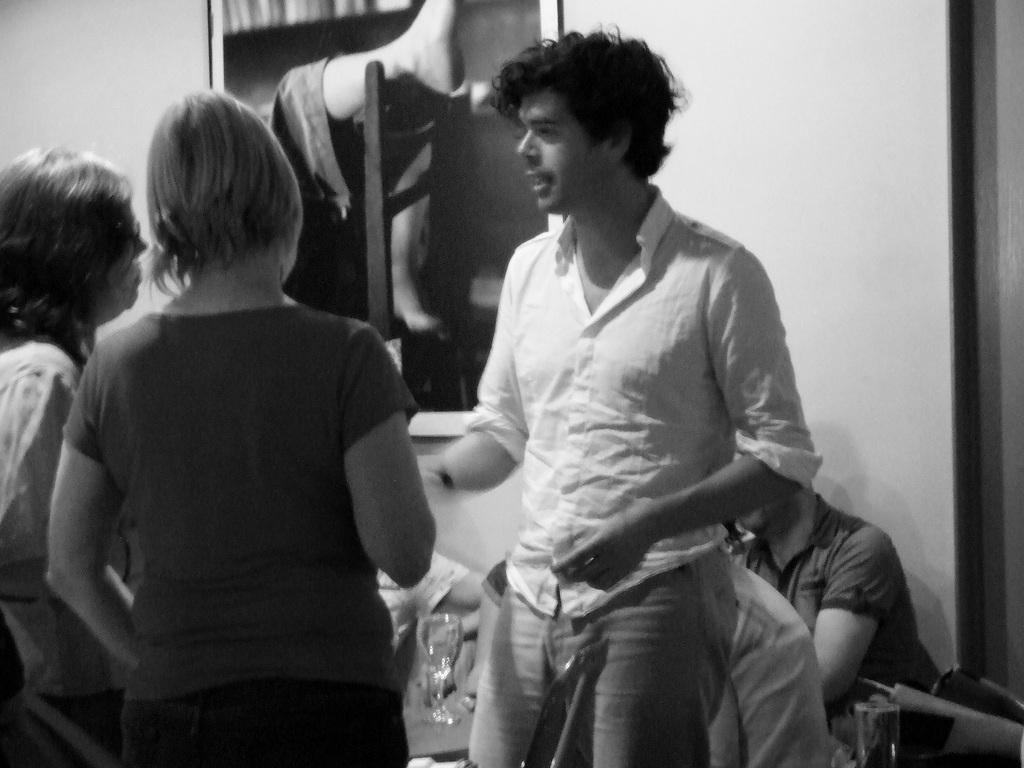What can be seen in the image? There is a group of people in the image. Can you describe the composition of the group? There are men and women in the image. Is there any object visible on the wall in the background? Yes, there is a photo frame on the wall in the background of the image. How many giants are present in the image? There are no giants present in the image; it features a group of people, including men and women. 